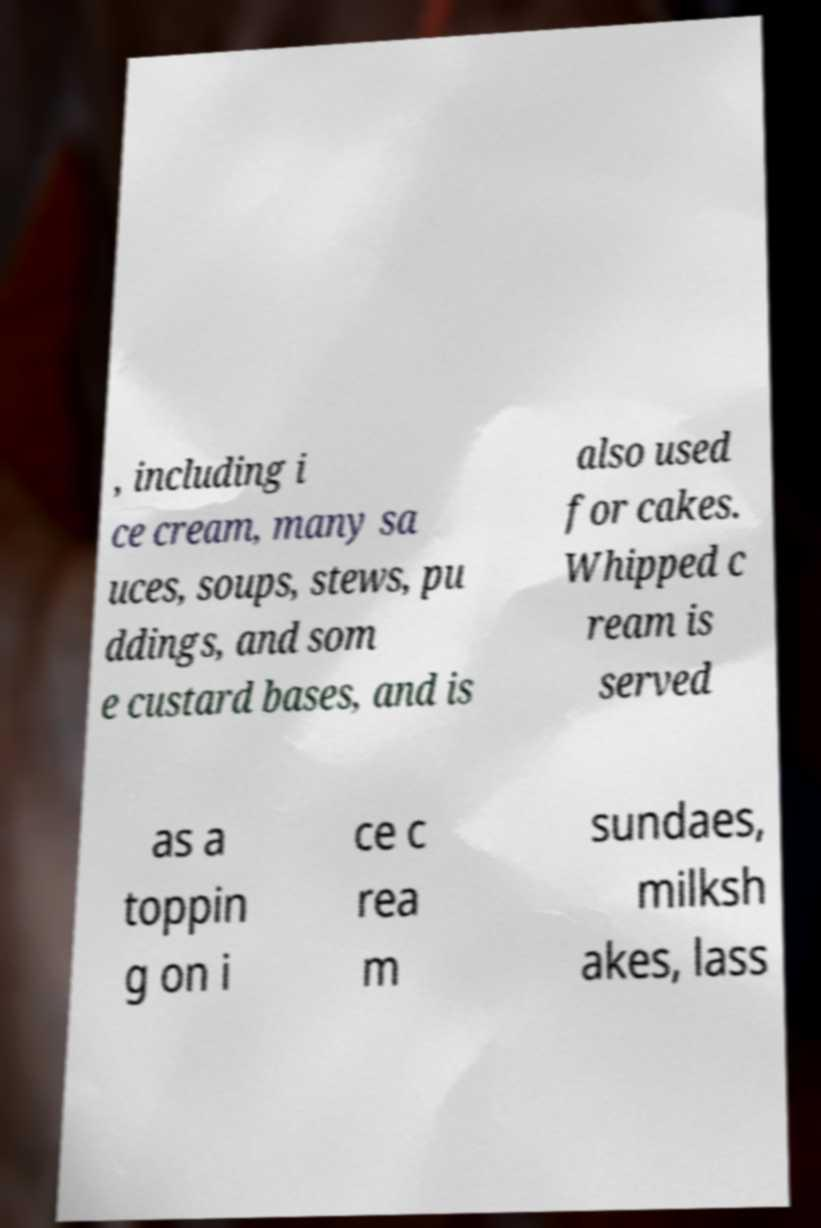Could you extract and type out the text from this image? , including i ce cream, many sa uces, soups, stews, pu ddings, and som e custard bases, and is also used for cakes. Whipped c ream is served as a toppin g on i ce c rea m sundaes, milksh akes, lass 